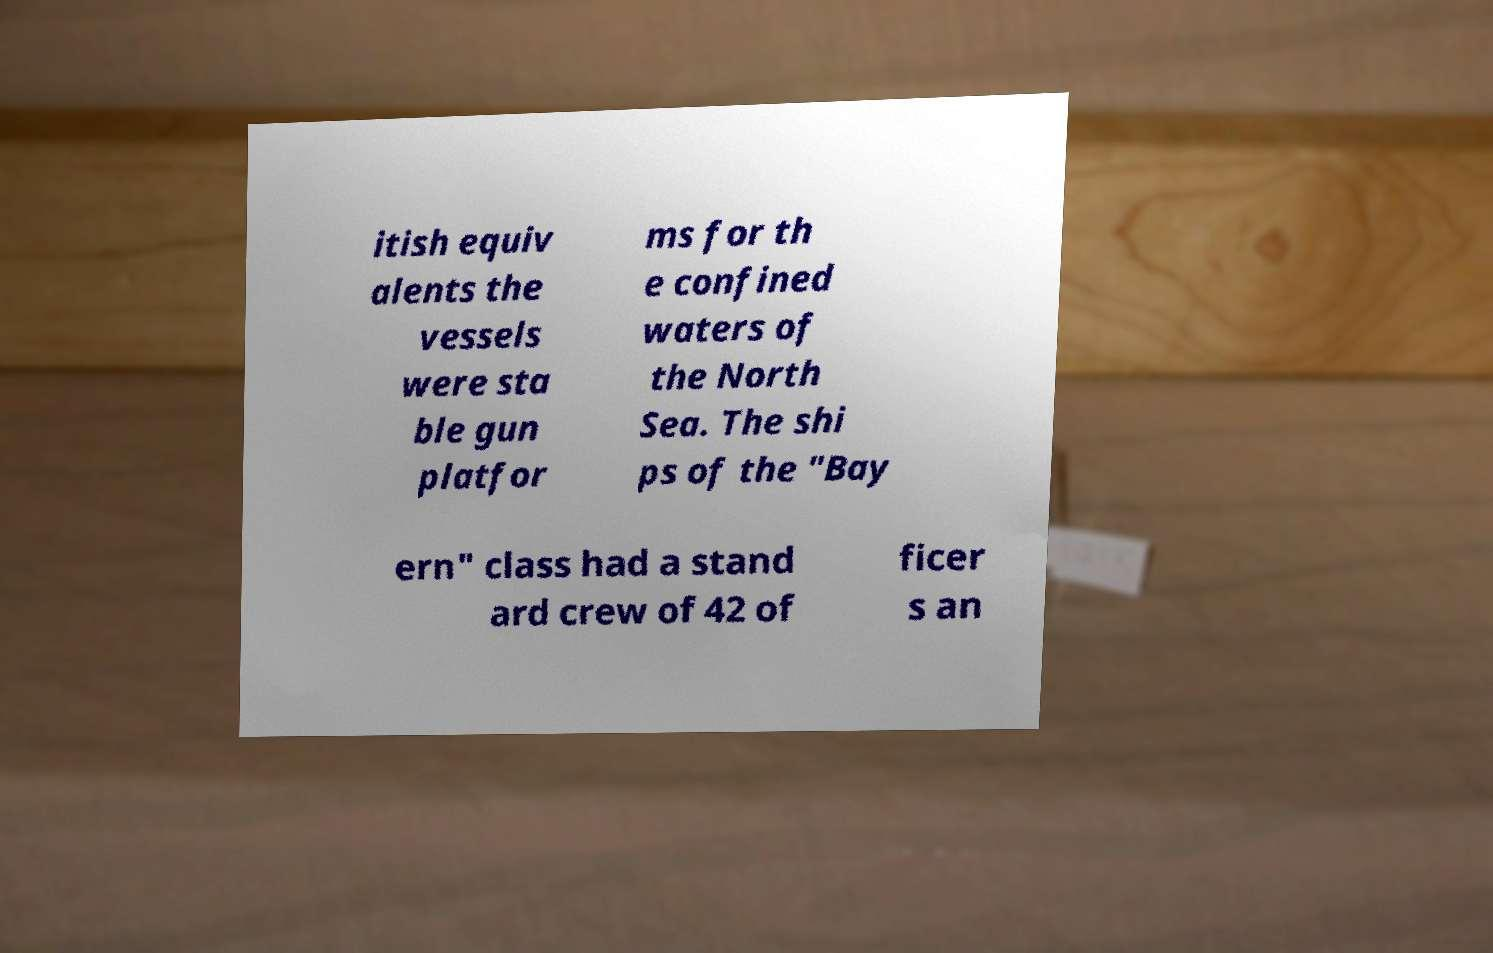Can you read and provide the text displayed in the image?This photo seems to have some interesting text. Can you extract and type it out for me? itish equiv alents the vessels were sta ble gun platfor ms for th e confined waters of the North Sea. The shi ps of the "Bay ern" class had a stand ard crew of 42 of ficer s an 